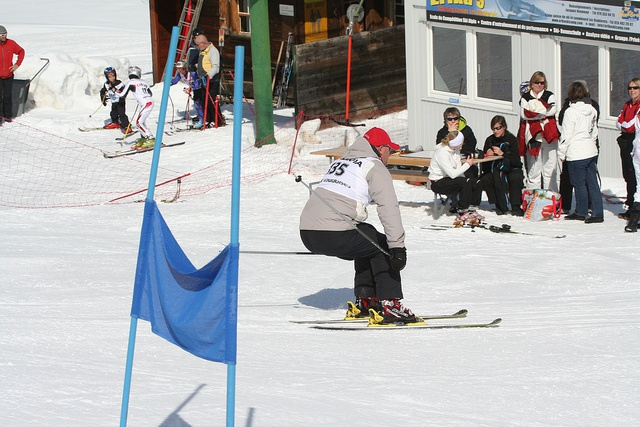Describe the objects in this image and their specific colors. I can see people in lightgray, black, and darkgray tones, people in lightgray, ivory, black, and gray tones, people in lightgray, gray, black, and darkgray tones, people in lightgray, black, gray, maroon, and brown tones, and people in lightgray, black, darkgray, and gray tones in this image. 